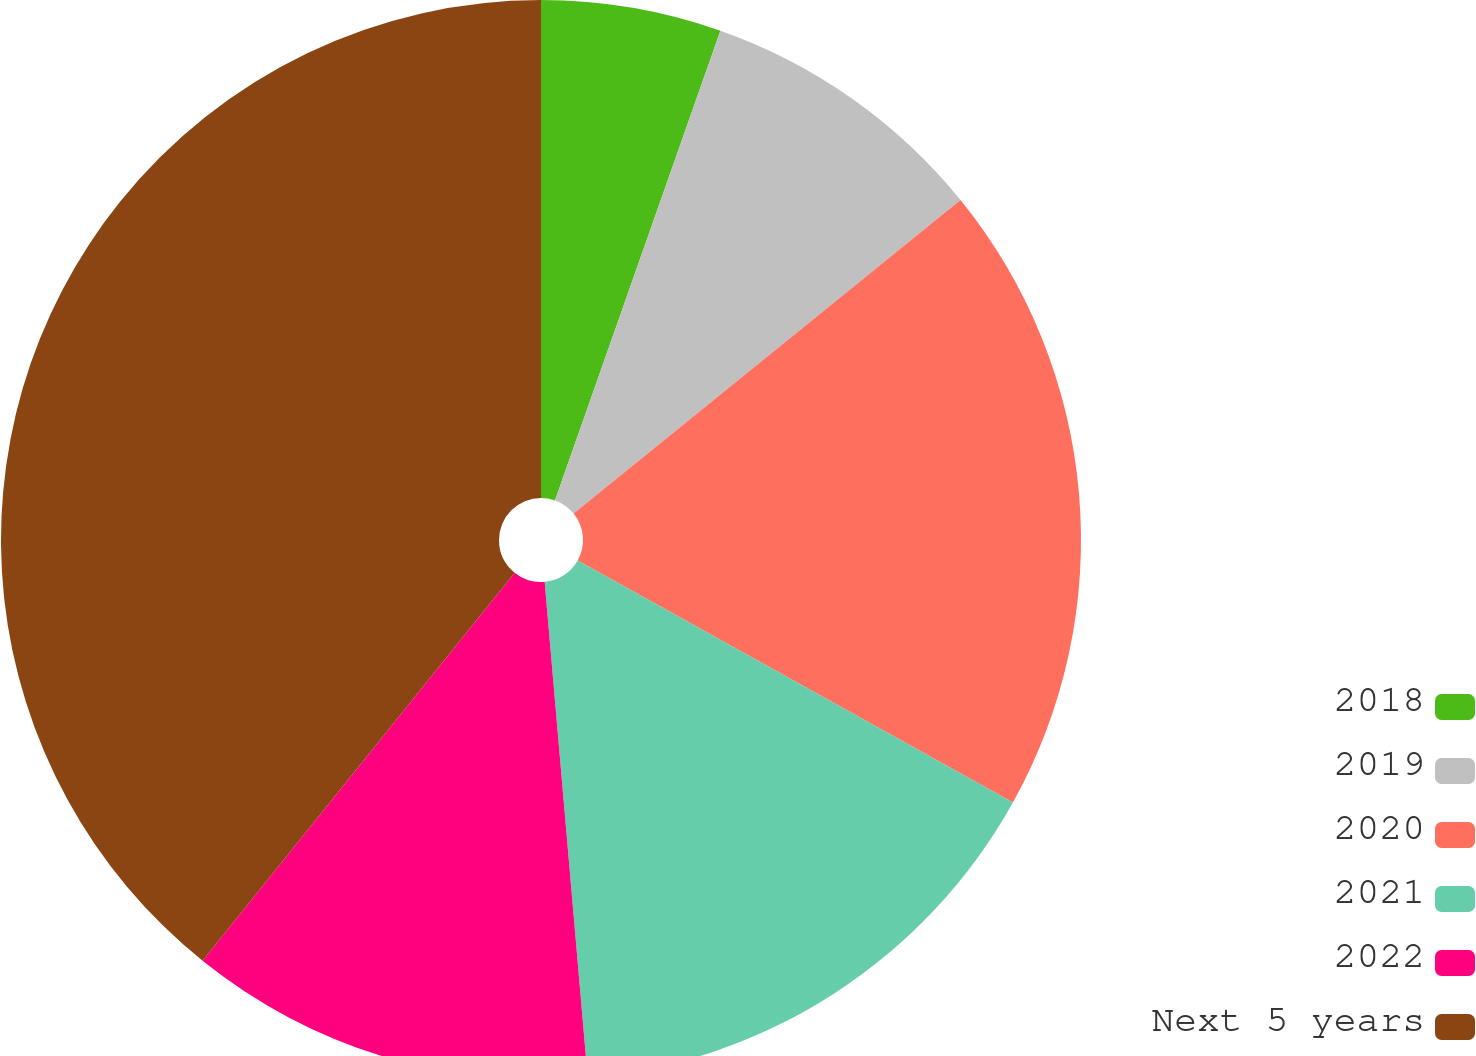Convert chart. <chart><loc_0><loc_0><loc_500><loc_500><pie_chart><fcel>2018<fcel>2019<fcel>2020<fcel>2021<fcel>2022<fcel>Next 5 years<nl><fcel>5.39%<fcel>8.77%<fcel>18.92%<fcel>15.54%<fcel>12.16%<fcel>39.22%<nl></chart> 